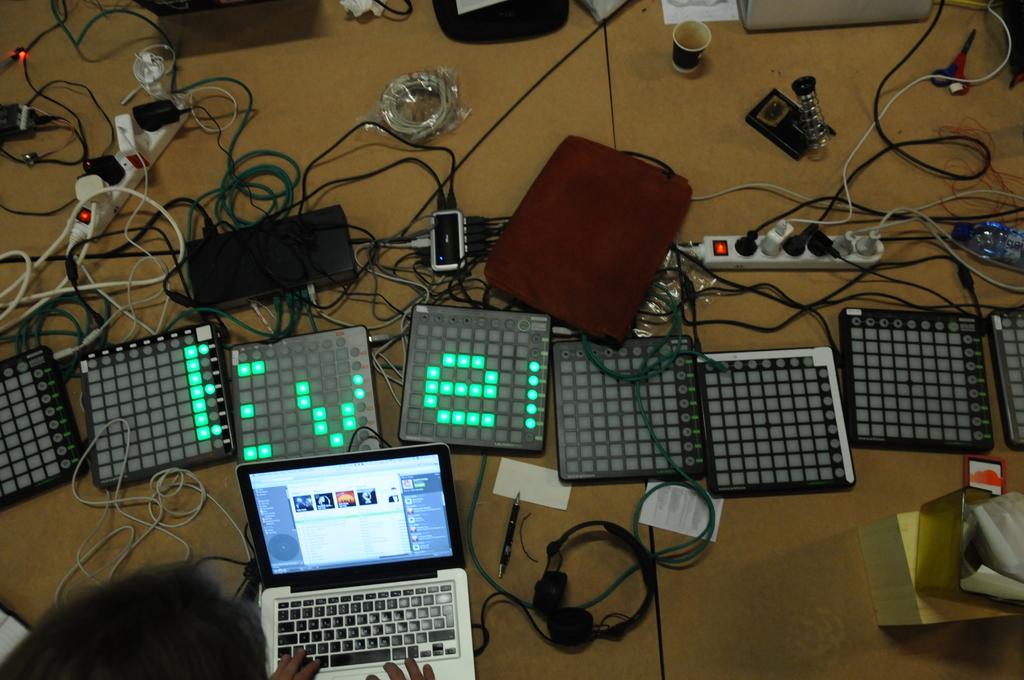What letter is displayed on the board under the red bag?
Ensure brevity in your answer.  E. What letter is on the 2nd screen?
Your answer should be very brief. V. 